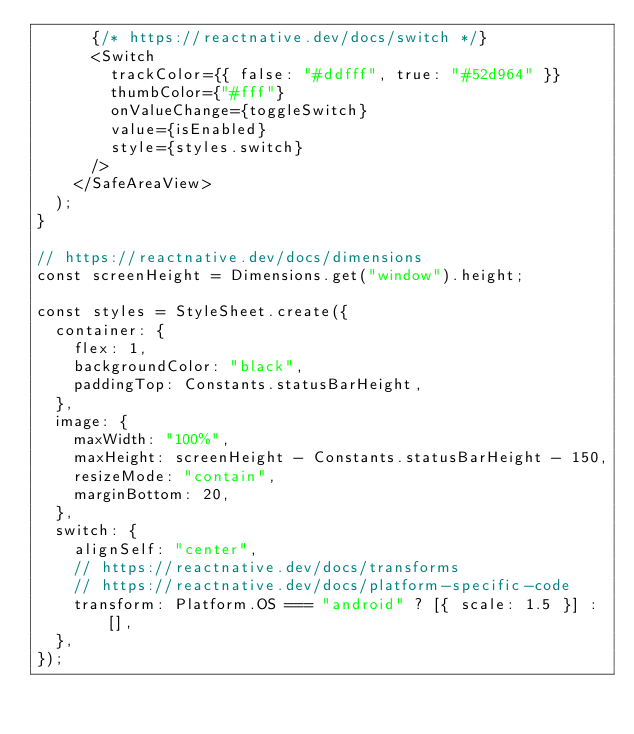Convert code to text. <code><loc_0><loc_0><loc_500><loc_500><_JavaScript_>      {/* https://reactnative.dev/docs/switch */}
      <Switch
        trackColor={{ false: "#ddfff", true: "#52d964" }}
        thumbColor={"#fff"}
        onValueChange={toggleSwitch}
        value={isEnabled}
        style={styles.switch}
      />
    </SafeAreaView>
  );
}

// https://reactnative.dev/docs/dimensions
const screenHeight = Dimensions.get("window").height;

const styles = StyleSheet.create({
  container: {
    flex: 1,
    backgroundColor: "black",
    paddingTop: Constants.statusBarHeight,
  },
  image: {
    maxWidth: "100%",
    maxHeight: screenHeight - Constants.statusBarHeight - 150,
    resizeMode: "contain",
    marginBottom: 20,
  },
  switch: {
    alignSelf: "center",
    // https://reactnative.dev/docs/transforms
    // https://reactnative.dev/docs/platform-specific-code
    transform: Platform.OS === "android" ? [{ scale: 1.5 }] : [],
  },
});
</code> 